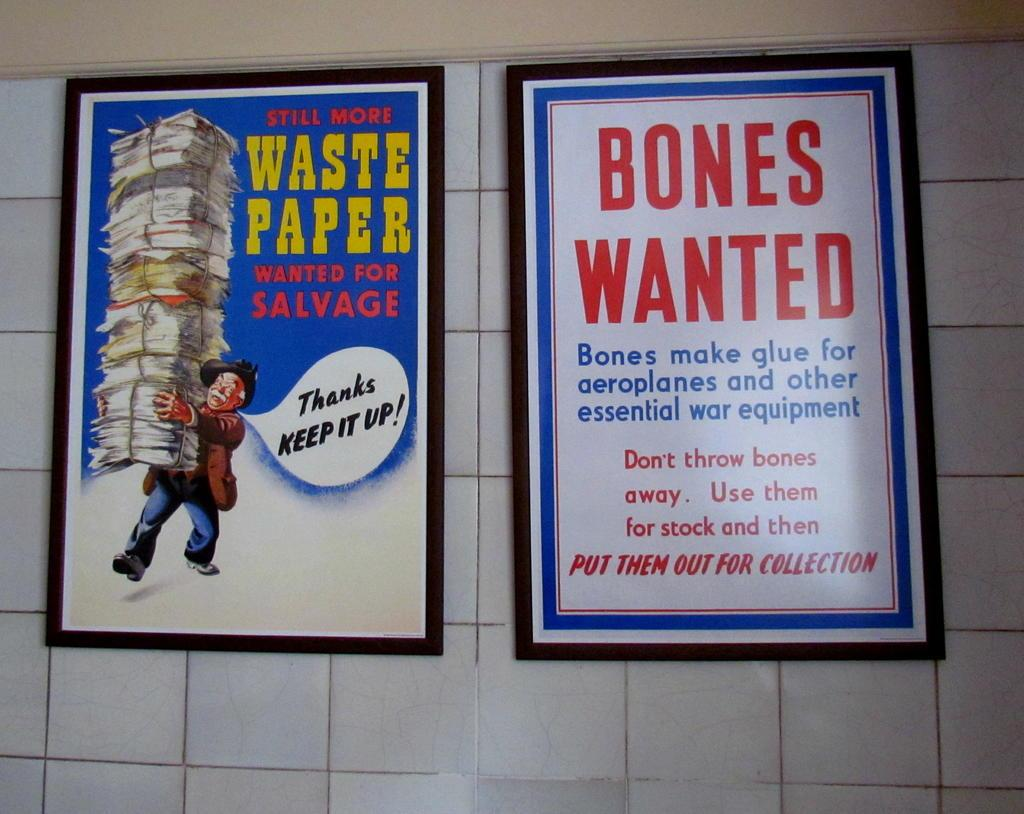Provide a one-sentence caption for the provided image. The two prints on the wall have funny comments about paper and bones. 